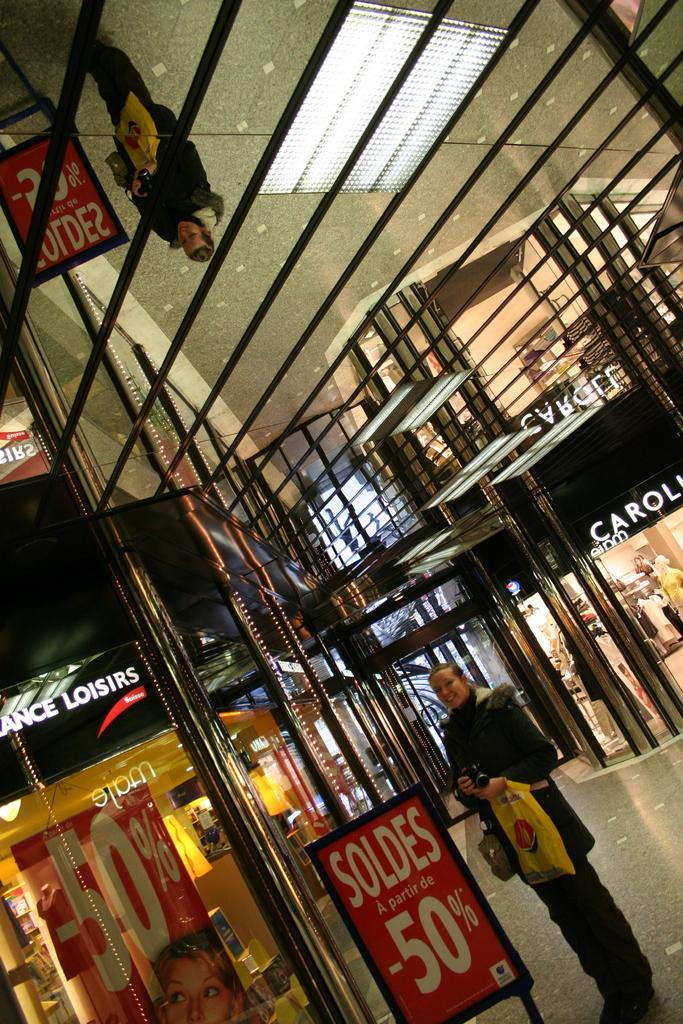What type of establishment is shown in the image? There is a store in the image. What can be found inside the store to help customers navigate or learn about products? There are information boards in the image. What type of lighting is used in the store? Electric lights are visible in the image. What material is used to cover the windows or doors in the store? There is an iron mesh in the image. Can you describe the woman's position in the image? A woman is standing on the ground in the image. Is the woman sitting on a chair in the image? There is no chair present in the image, and the woman is standing on the ground. What type of play is happening in the image? There is no play or any indication of a play in the image. 